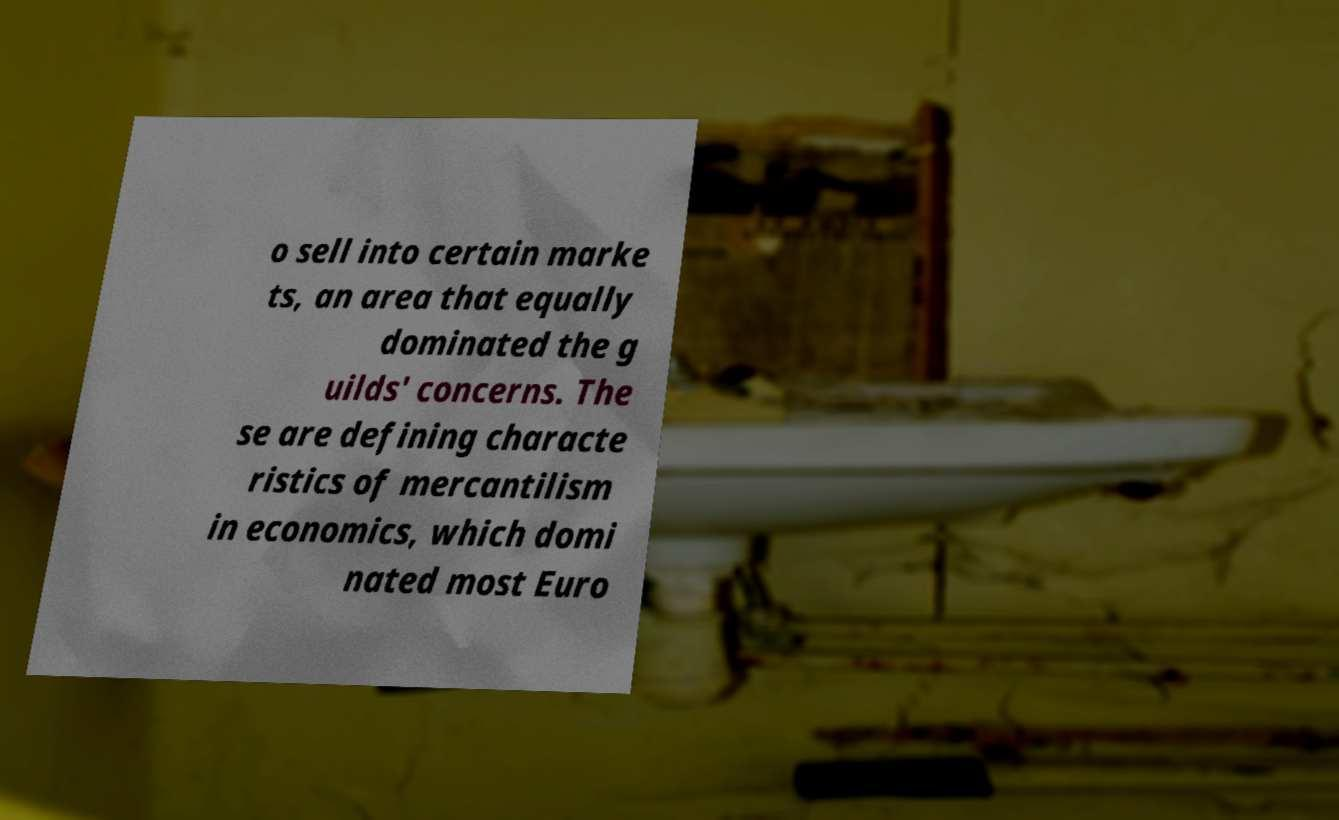Can you accurately transcribe the text from the provided image for me? o sell into certain marke ts, an area that equally dominated the g uilds' concerns. The se are defining characte ristics of mercantilism in economics, which domi nated most Euro 